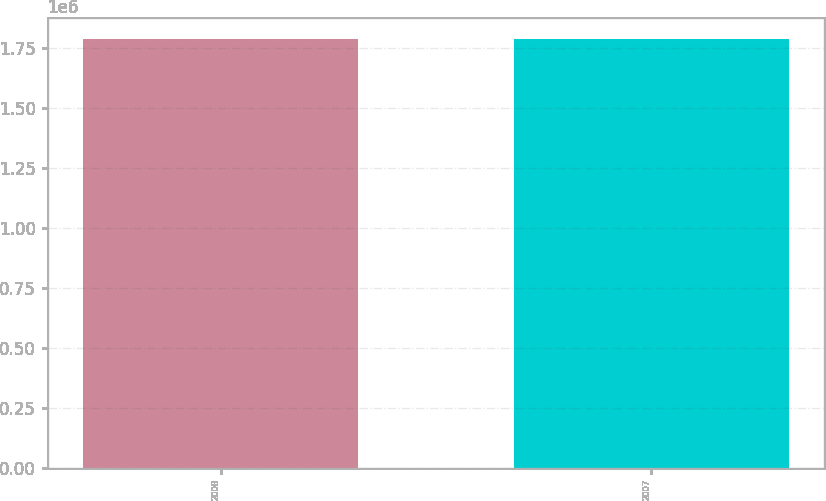Convert chart to OTSL. <chart><loc_0><loc_0><loc_500><loc_500><bar_chart><fcel>2008<fcel>2007<nl><fcel>1.789e+06<fcel>1.789e+06<nl></chart> 